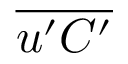<formula> <loc_0><loc_0><loc_500><loc_500>\overline { { u ^ { \prime } C ^ { \prime } } }</formula> 